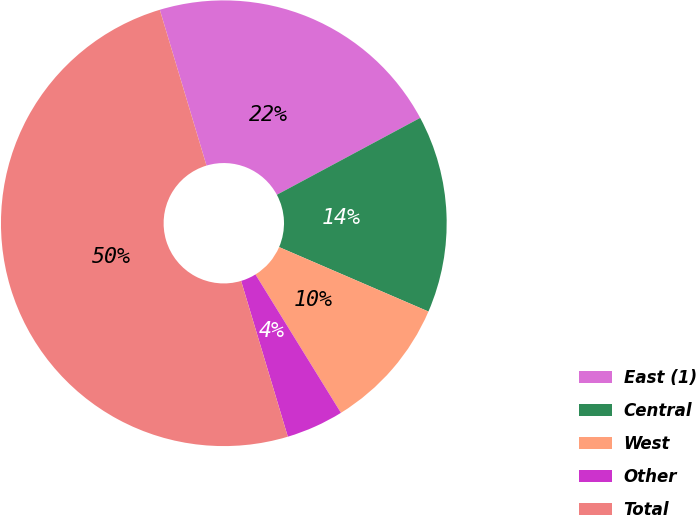Convert chart. <chart><loc_0><loc_0><loc_500><loc_500><pie_chart><fcel>East (1)<fcel>Central<fcel>West<fcel>Other<fcel>Total<nl><fcel>21.8%<fcel>14.32%<fcel>9.71%<fcel>4.17%<fcel>50.0%<nl></chart> 